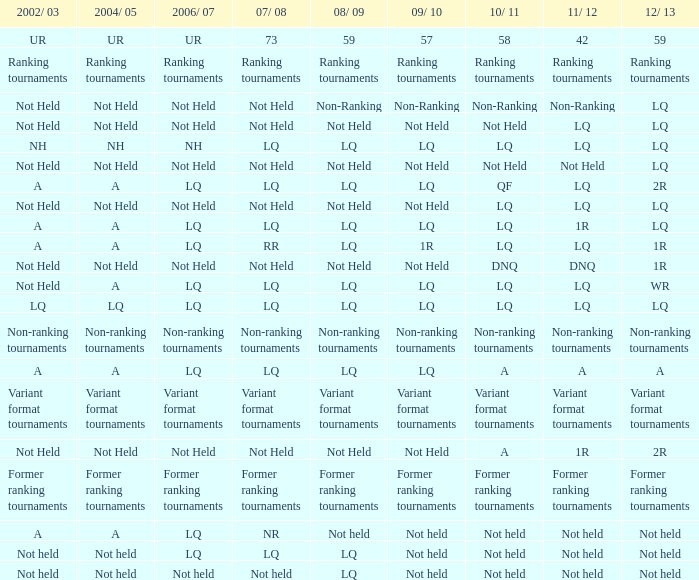Name the 2010/11 with 2004/05 of not held and 2011/12 of non-ranking Non-Ranking. 